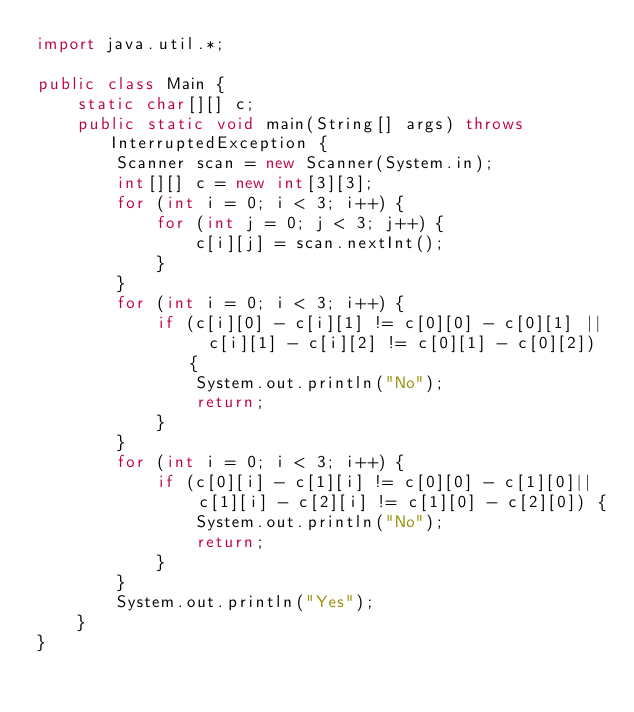Convert code to text. <code><loc_0><loc_0><loc_500><loc_500><_Java_>import java.util.*;

public class Main {
    static char[][] c;
    public static void main(String[] args) throws InterruptedException {
        Scanner scan = new Scanner(System.in);
        int[][] c = new int[3][3];
        for (int i = 0; i < 3; i++) {
            for (int j = 0; j < 3; j++) {
                c[i][j] = scan.nextInt();
            }
        }
        for (int i = 0; i < 3; i++) {
            if (c[i][0] - c[i][1] != c[0][0] - c[0][1] ||  c[i][1] - c[i][2] != c[0][1] - c[0][2]) {
                System.out.println("No");
                return;
            }
        }
        for (int i = 0; i < 3; i++) {
            if (c[0][i] - c[1][i] != c[0][0] - c[1][0]||  c[1][i] - c[2][i] != c[1][0] - c[2][0]) {
                System.out.println("No");
                return;
            }
        }
        System.out.println("Yes");
    }
}
</code> 